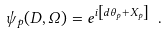<formula> <loc_0><loc_0><loc_500><loc_500>\psi _ { p } ( D , \Omega ) = e ^ { i \left [ d \theta _ { p } + X _ { p } \right ] } \ .</formula> 